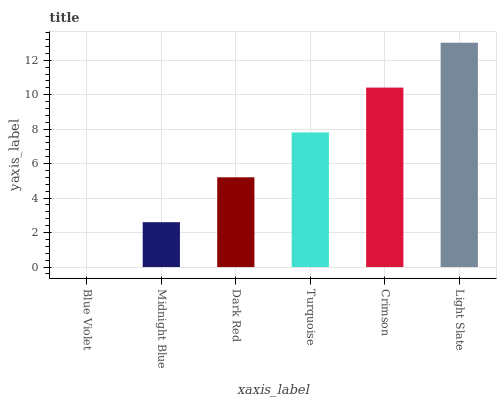Is Blue Violet the minimum?
Answer yes or no. Yes. Is Light Slate the maximum?
Answer yes or no. Yes. Is Midnight Blue the minimum?
Answer yes or no. No. Is Midnight Blue the maximum?
Answer yes or no. No. Is Midnight Blue greater than Blue Violet?
Answer yes or no. Yes. Is Blue Violet less than Midnight Blue?
Answer yes or no. Yes. Is Blue Violet greater than Midnight Blue?
Answer yes or no. No. Is Midnight Blue less than Blue Violet?
Answer yes or no. No. Is Turquoise the high median?
Answer yes or no. Yes. Is Dark Red the low median?
Answer yes or no. Yes. Is Dark Red the high median?
Answer yes or no. No. Is Turquoise the low median?
Answer yes or no. No. 